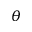Convert formula to latex. <formula><loc_0><loc_0><loc_500><loc_500>\theta</formula> 